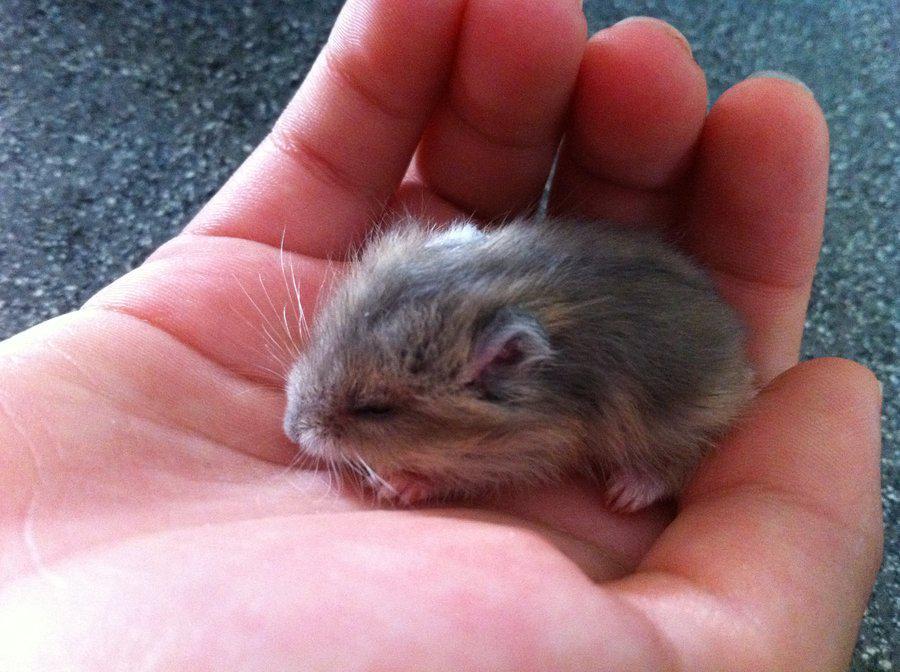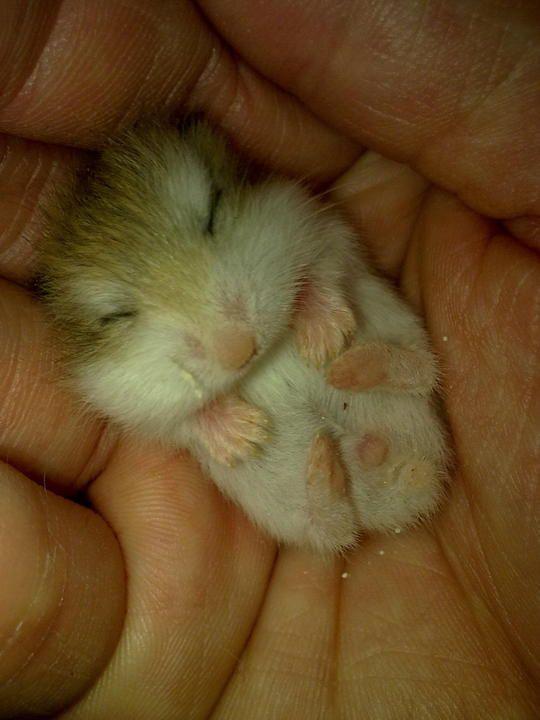The first image is the image on the left, the second image is the image on the right. Examine the images to the left and right. Is the description "There is exactly one sleeping rodent in the hand of a human in the image on the right." accurate? Answer yes or no. Yes. 